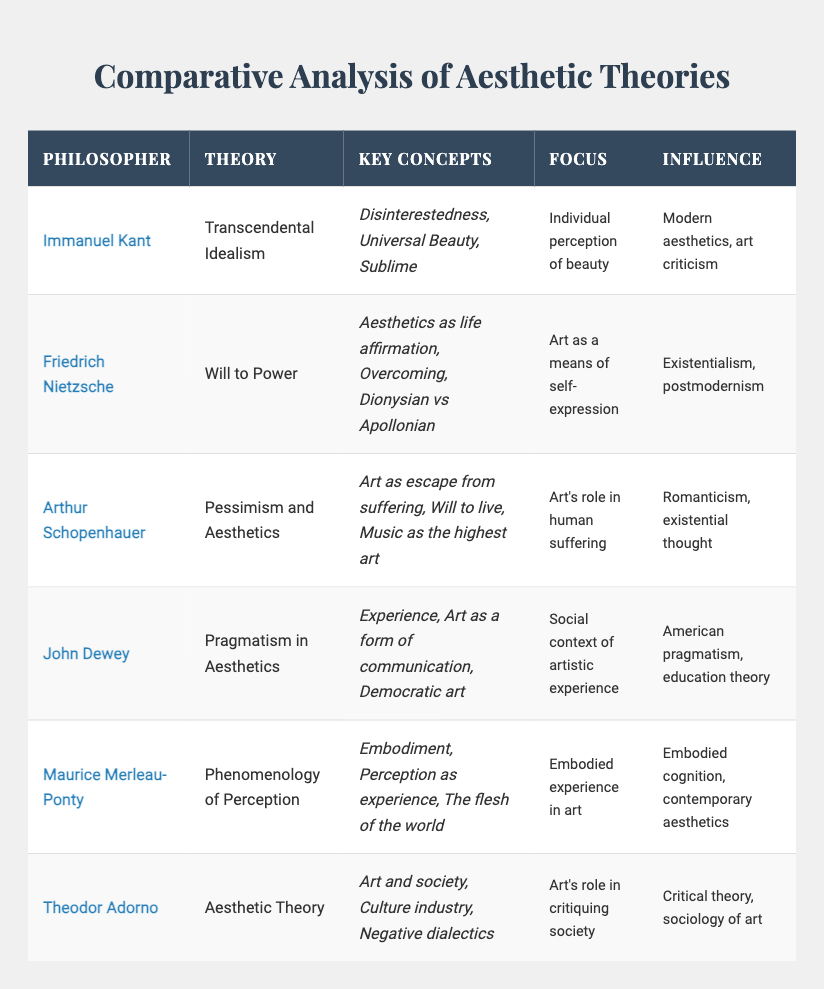What philosophy did John Dewey contribute to aesthetics? The table indicates that John Dewey contributed the theory of Pragmatism in Aesthetics. This is explicitly stated in the column for 'Theory' under Dewey's name.
Answer: Pragmatism in Aesthetics Which philosopher's theory focuses on the individual perception of beauty? According to the table, Immanuel Kant's theory, Transcendental Idealism, emphasizes the individual perception of beauty. This focus is detailed in the respective column.
Answer: Immanuel Kant True or False: Theodor Adorno's theory includes the concept of the culture industry. The table specifies in Adorno's 'Key Concepts' that "Culture industry" is indeed one of the concepts involved in his Aesthetic Theory. Therefore, the statement is true.
Answer: True Which two philosophers have the influence of existential thought? By examining the influence section of the table, Friedrich Nietzsche's influence includes existentialism, while Arthur Schopenhauer's influence is designated as existential thought. The answer is derived by identifying these philosophers and their shared influence.
Answer: Friedrich Nietzsche and Arthur Schopenhauer What is the average number of key concepts associated with the philosophers listed? We count the key concepts: Kant (3), Nietzsche (3), Schopenhauer (3), Dewey (3), Merleau-Ponty (3), Adorno (3), totaling 18 concepts across 6 philosophers. Dividing 18 by 6 gives us an average of 3 key concepts per philosopher.
Answer: 3 